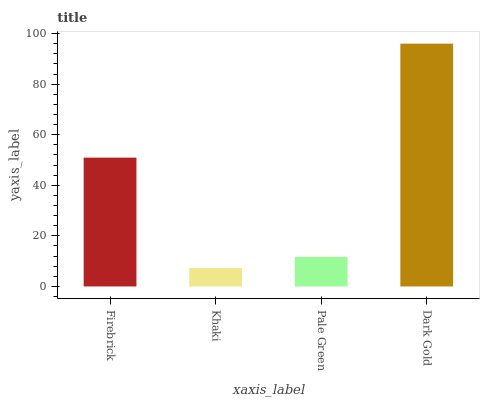Is Khaki the minimum?
Answer yes or no. Yes. Is Dark Gold the maximum?
Answer yes or no. Yes. Is Pale Green the minimum?
Answer yes or no. No. Is Pale Green the maximum?
Answer yes or no. No. Is Pale Green greater than Khaki?
Answer yes or no. Yes. Is Khaki less than Pale Green?
Answer yes or no. Yes. Is Khaki greater than Pale Green?
Answer yes or no. No. Is Pale Green less than Khaki?
Answer yes or no. No. Is Firebrick the high median?
Answer yes or no. Yes. Is Pale Green the low median?
Answer yes or no. Yes. Is Dark Gold the high median?
Answer yes or no. No. Is Khaki the low median?
Answer yes or no. No. 